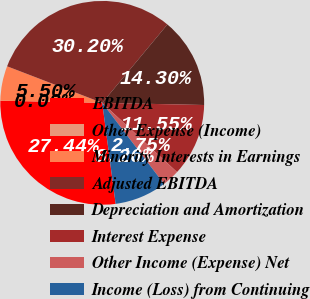<chart> <loc_0><loc_0><loc_500><loc_500><pie_chart><fcel>EBITDA<fcel>Other Expense (Income)<fcel>Minority Interests in Earnings<fcel>Adjusted EBITDA<fcel>Depreciation and Amortization<fcel>Interest Expense<fcel>Other Income (Expense) Net<fcel>Income (Loss) from Continuing<nl><fcel>27.44%<fcel>0.0%<fcel>5.5%<fcel>30.2%<fcel>14.3%<fcel>11.55%<fcel>2.75%<fcel>8.26%<nl></chart> 